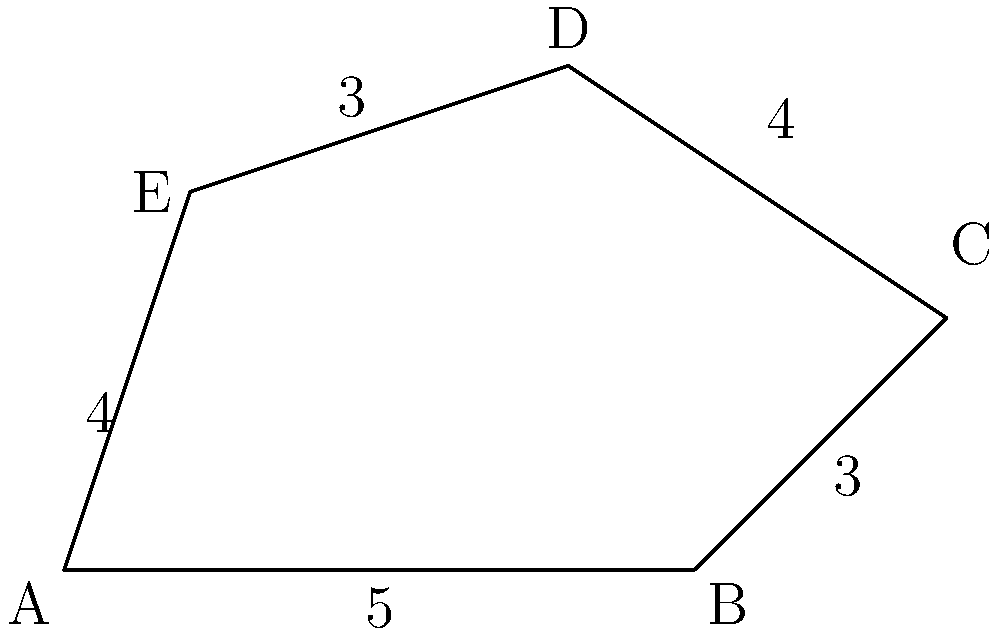A private property has an irregular pentagonal shape as shown in the diagram. The lengths of four sides are given: AB = 5 units, BC = 3 units, CD = 4 units, and DE = 3 units. If the perimeter of the property is 19 units, what is the length of side EA? To find the length of side EA, we can follow these steps:

1. Identify the known information:
   - The shape is an irregular pentagon
   - AB = 5 units
   - BC = 3 units
   - CD = 4 units
   - DE = 3 units
   - Total perimeter = 19 units

2. Calculate the sum of the known sides:
   $5 + 3 + 4 + 3 = 15$ units

3. Use the perimeter formula:
   Perimeter = Sum of all sides
   $19 = 15 + EA$

4. Solve for EA:
   $EA = 19 - 15 = 4$ units

Therefore, the length of side EA is 4 units.
Answer: 4 units 